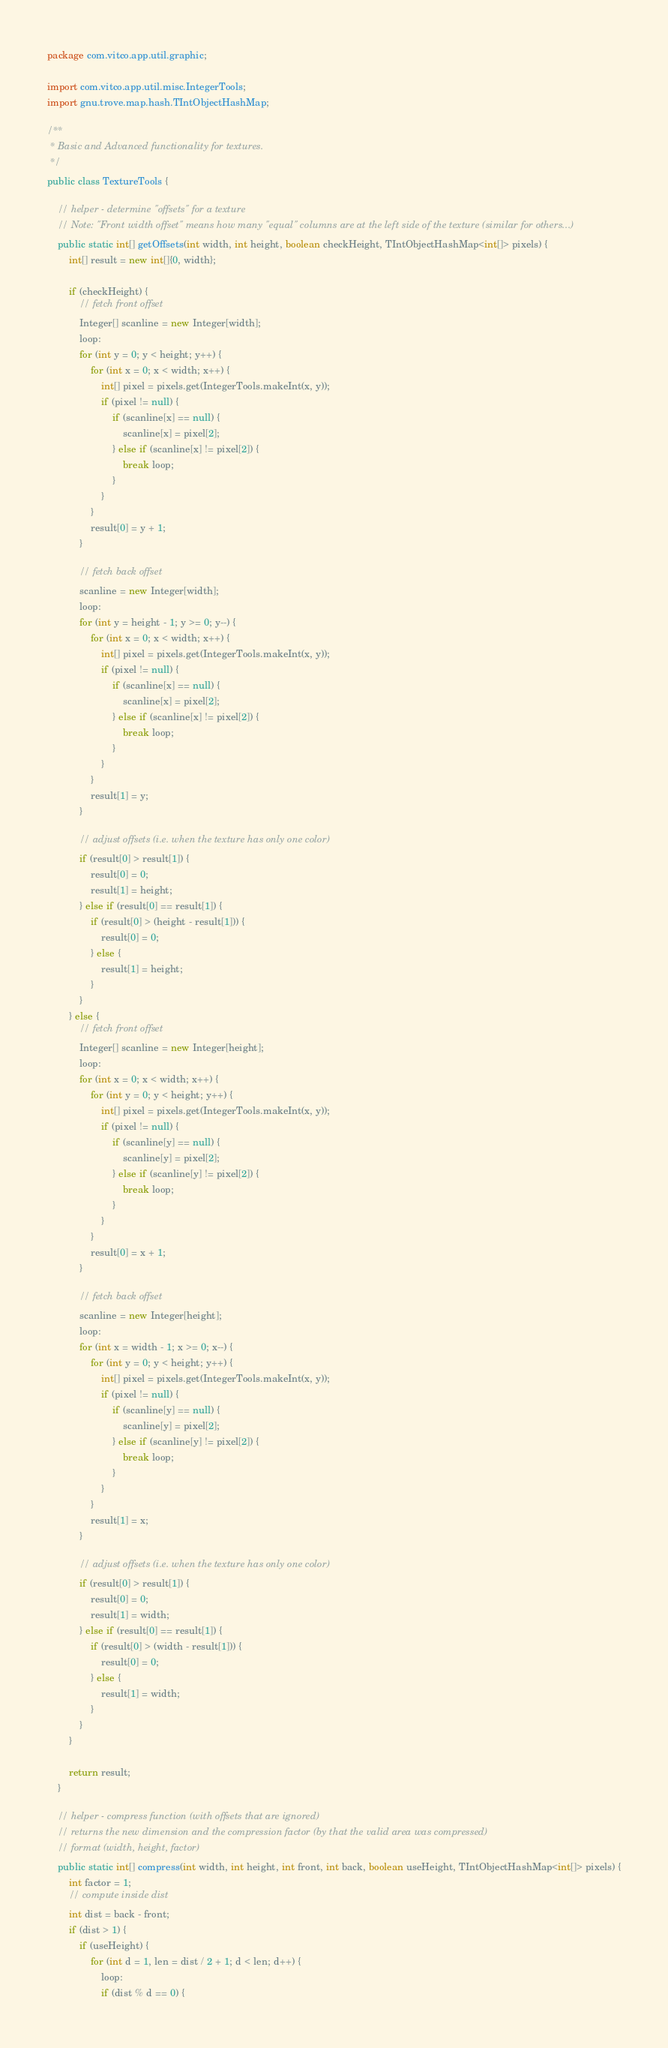Convert code to text. <code><loc_0><loc_0><loc_500><loc_500><_Java_>package com.vitco.app.util.graphic;

import com.vitco.app.util.misc.IntegerTools;
import gnu.trove.map.hash.TIntObjectHashMap;

/**
 * Basic and Advanced functionality for textures.
 */
public class TextureTools {

    // helper - determine "offsets" for a texture
    // Note: "Front width offset" means how many "equal" columns are at the left side of the texture (similar for others...)
    public static int[] getOffsets(int width, int height, boolean checkHeight, TIntObjectHashMap<int[]> pixels) {
        int[] result = new int[]{0, width};

        if (checkHeight) {
            // fetch front offset
            Integer[] scanline = new Integer[width];
            loop:
            for (int y = 0; y < height; y++) {
                for (int x = 0; x < width; x++) {
                    int[] pixel = pixels.get(IntegerTools.makeInt(x, y));
                    if (pixel != null) {
                        if (scanline[x] == null) {
                            scanline[x] = pixel[2];
                        } else if (scanline[x] != pixel[2]) {
                            break loop;
                        }
                    }
                }
                result[0] = y + 1;
            }

            // fetch back offset
            scanline = new Integer[width];
            loop:
            for (int y = height - 1; y >= 0; y--) {
                for (int x = 0; x < width; x++) {
                    int[] pixel = pixels.get(IntegerTools.makeInt(x, y));
                    if (pixel != null) {
                        if (scanline[x] == null) {
                            scanline[x] = pixel[2];
                        } else if (scanline[x] != pixel[2]) {
                            break loop;
                        }
                    }
                }
                result[1] = y;
            }

            // adjust offsets (i.e. when the texture has only one color)
            if (result[0] > result[1]) {
                result[0] = 0;
                result[1] = height;
            } else if (result[0] == result[1]) {
                if (result[0] > (height - result[1])) {
                    result[0] = 0;
                } else {
                    result[1] = height;
                }
            }
        } else {
            // fetch front offset
            Integer[] scanline = new Integer[height];
            loop:
            for (int x = 0; x < width; x++) {
                for (int y = 0; y < height; y++) {
                    int[] pixel = pixels.get(IntegerTools.makeInt(x, y));
                    if (pixel != null) {
                        if (scanline[y] == null) {
                            scanline[y] = pixel[2];
                        } else if (scanline[y] != pixel[2]) {
                            break loop;
                        }
                    }
                }
                result[0] = x + 1;
            }

            // fetch back offset
            scanline = new Integer[height];
            loop:
            for (int x = width - 1; x >= 0; x--) {
                for (int y = 0; y < height; y++) {
                    int[] pixel = pixels.get(IntegerTools.makeInt(x, y));
                    if (pixel != null) {
                        if (scanline[y] == null) {
                            scanline[y] = pixel[2];
                        } else if (scanline[y] != pixel[2]) {
                            break loop;
                        }
                    }
                }
                result[1] = x;
            }

            // adjust offsets (i.e. when the texture has only one color)
            if (result[0] > result[1]) {
                result[0] = 0;
                result[1] = width;
            } else if (result[0] == result[1]) {
                if (result[0] > (width - result[1])) {
                    result[0] = 0;
                } else {
                    result[1] = width;
                }
            }
        }

        return result;
    }

    // helper - compress function (with offsets that are ignored)
    // returns the new dimension and the compression factor (by that the valid area was compressed)
    // format (width, height, factor)
    public static int[] compress(int width, int height, int front, int back, boolean useHeight, TIntObjectHashMap<int[]> pixels) {
        int factor = 1;
        // compute inside dist
        int dist = back - front;
        if (dist > 1) {
            if (useHeight) {
                for (int d = 1, len = dist / 2 + 1; d < len; d++) {
                    loop:
                    if (dist % d == 0) {</code> 